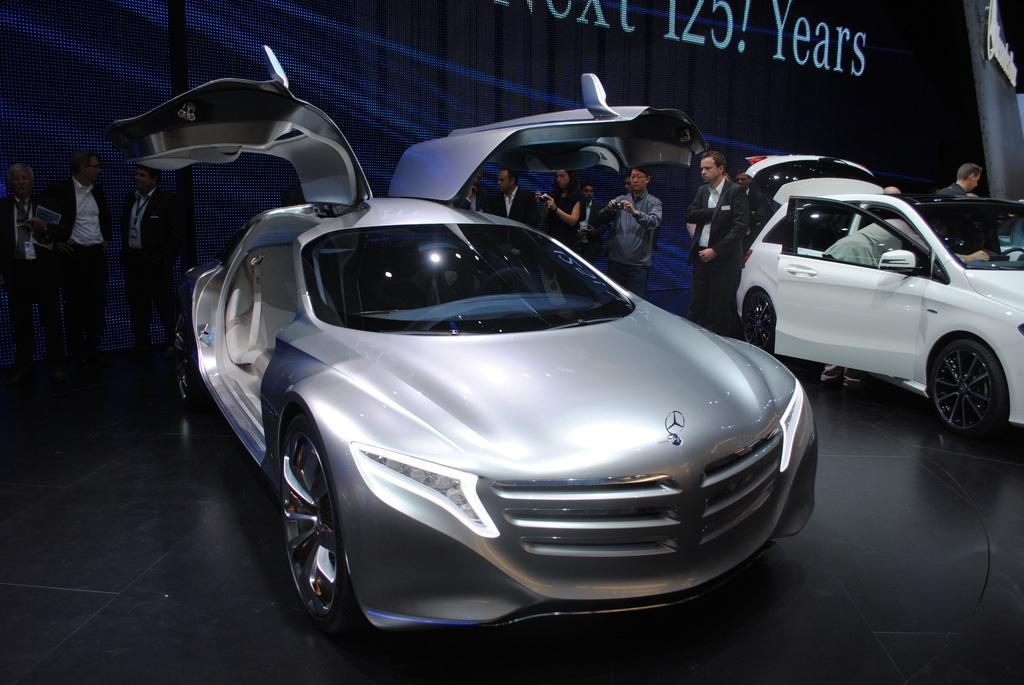Please provide a concise description of this image. In the background we can see people standing and few are holding gadgets and taking snap. We can see cars on the floor. At the top there is something written. 